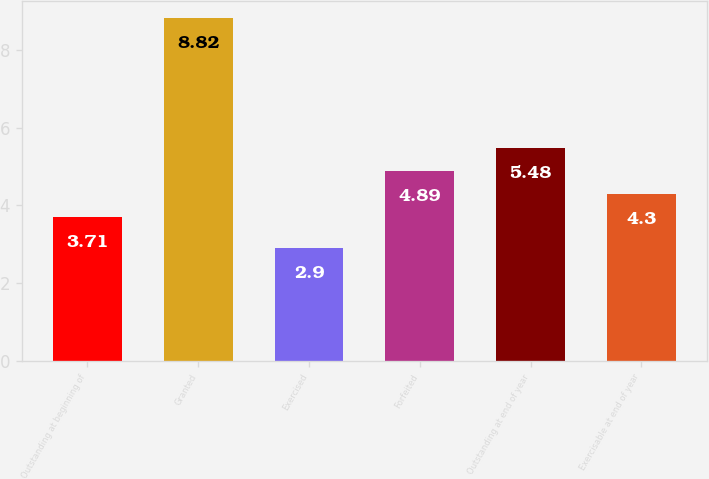Convert chart. <chart><loc_0><loc_0><loc_500><loc_500><bar_chart><fcel>Outstanding at beginning of<fcel>Granted<fcel>Exercised<fcel>Forfeited<fcel>Outstanding at end of year<fcel>Exercisable at end of year<nl><fcel>3.71<fcel>8.82<fcel>2.9<fcel>4.89<fcel>5.48<fcel>4.3<nl></chart> 